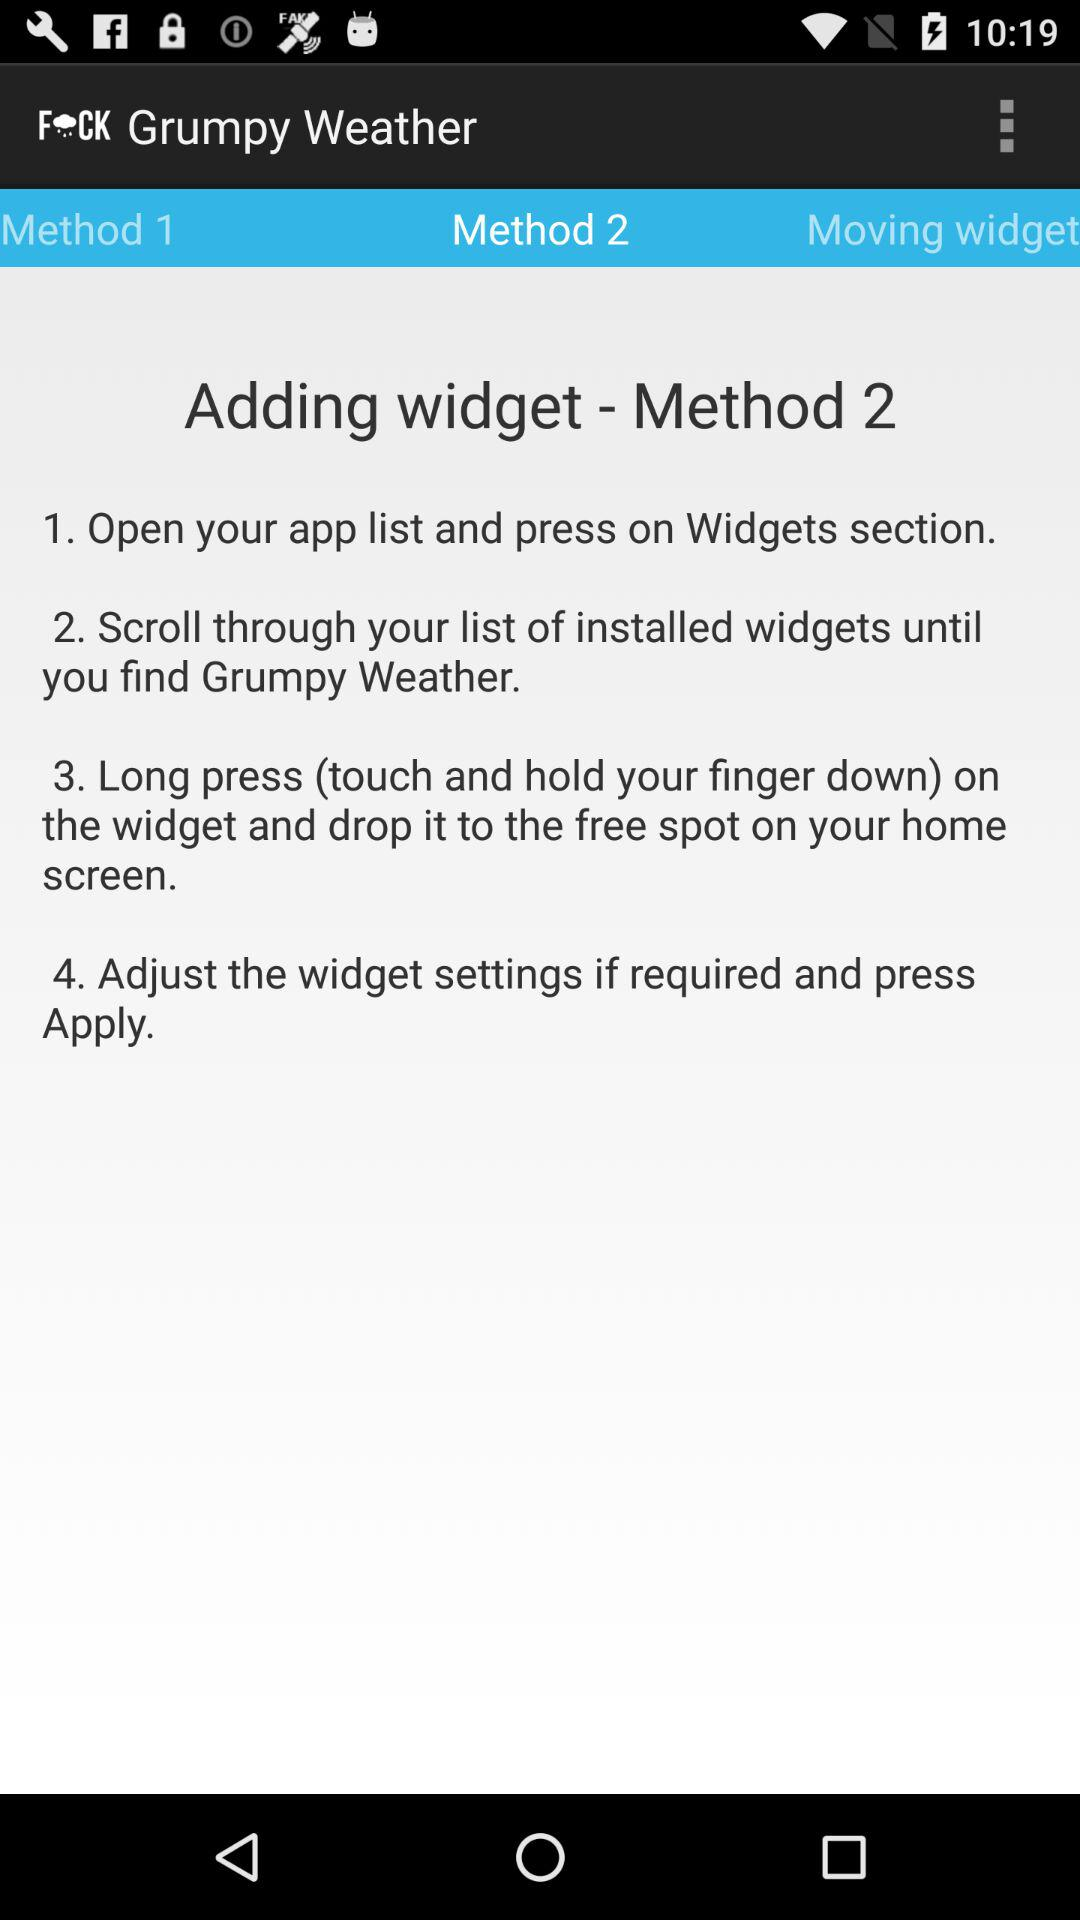What is the application name? The application name is "Grumpy Weather". 